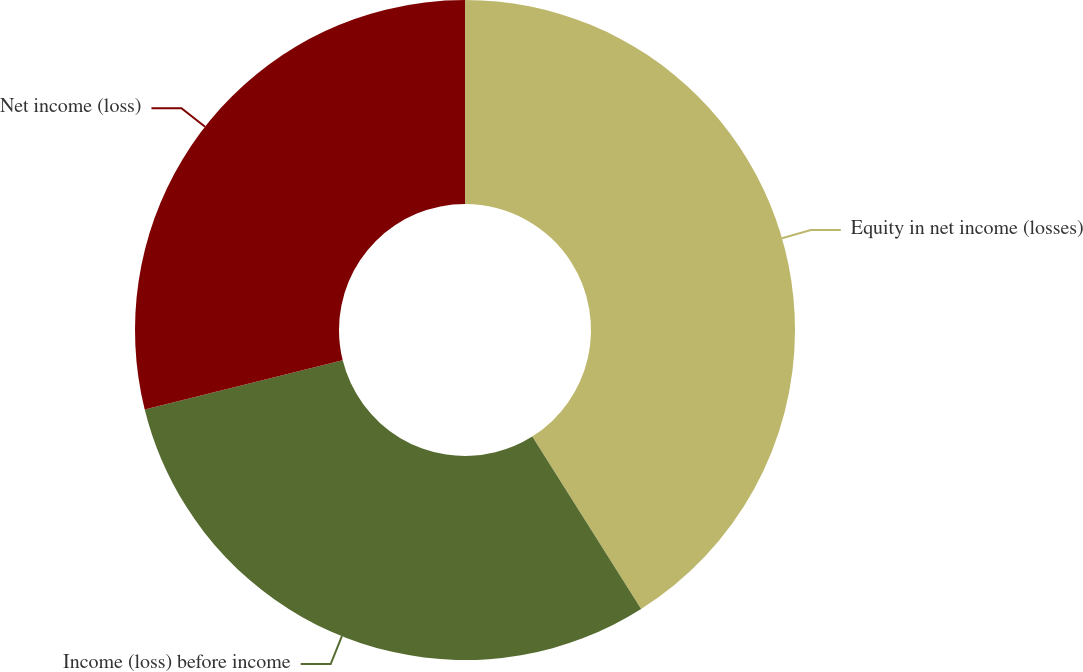Convert chart. <chart><loc_0><loc_0><loc_500><loc_500><pie_chart><fcel>Equity in net income (losses)<fcel>Income (loss) before income<fcel>Net income (loss)<nl><fcel>41.04%<fcel>30.09%<fcel>28.87%<nl></chart> 